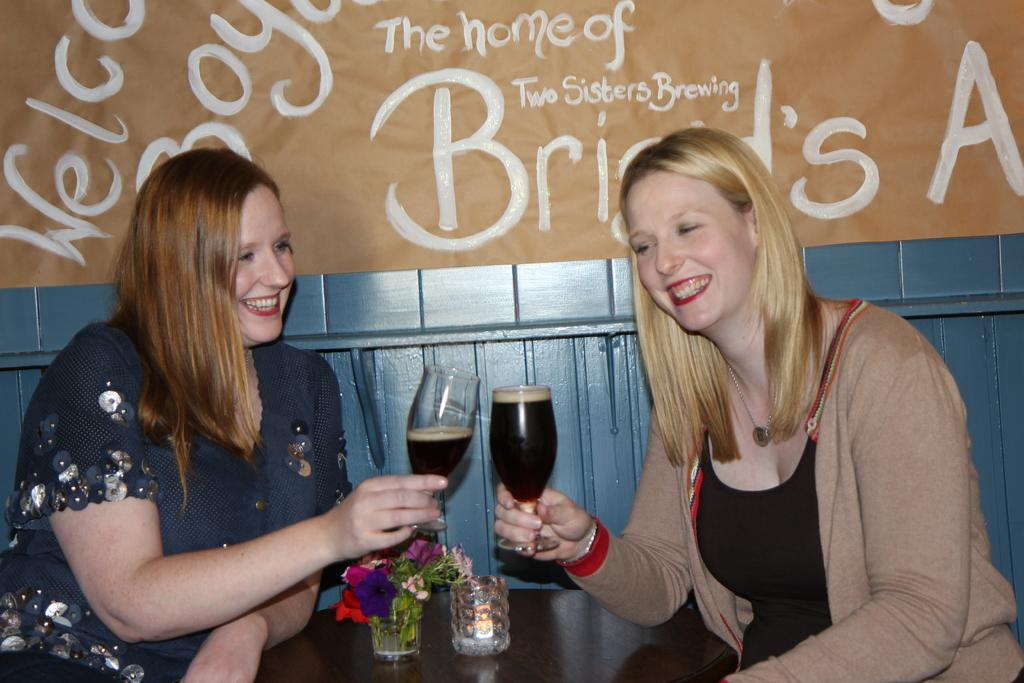How many people are in the image? There are two ladies in the image. What are the ladies doing in the image? The ladies are sitting on chairs and holding bottles. What is present on the table in the image? There is a small plant on the table. Is there any furniture in the image? Yes, there is a table in the image. How many children are playing with the button in the image? There are no children or buttons present in the image. 